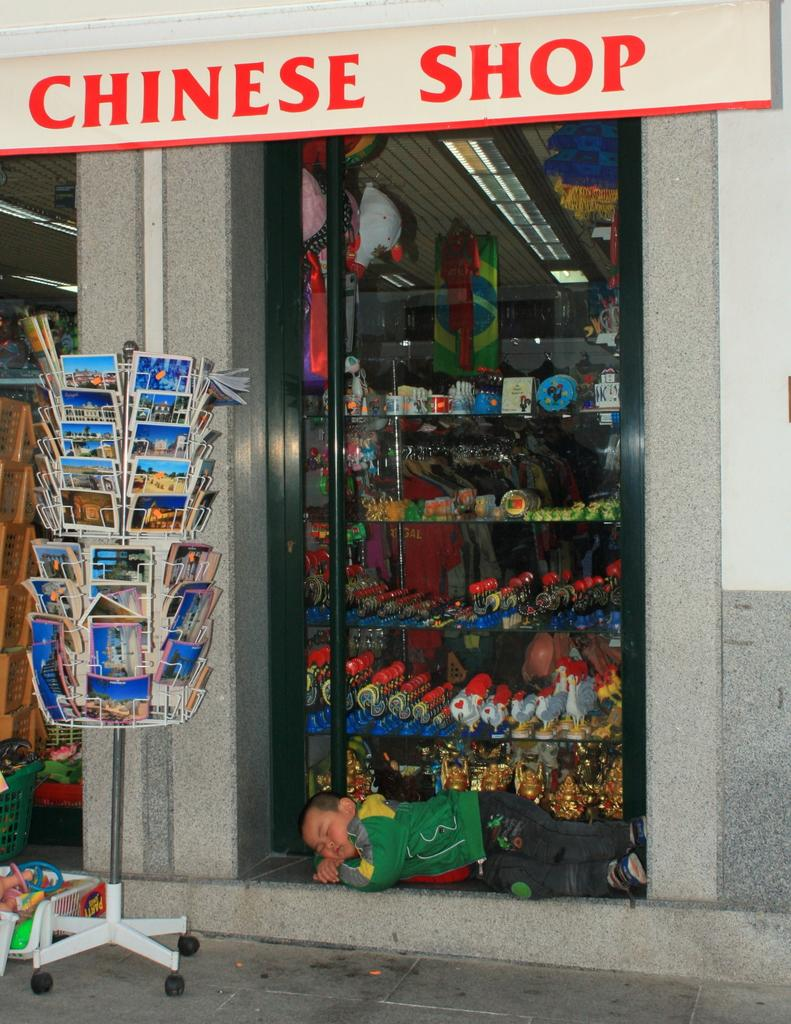<image>
Create a compact narrative representing the image presented. A Chinese shop sells post cards on a display out front. 